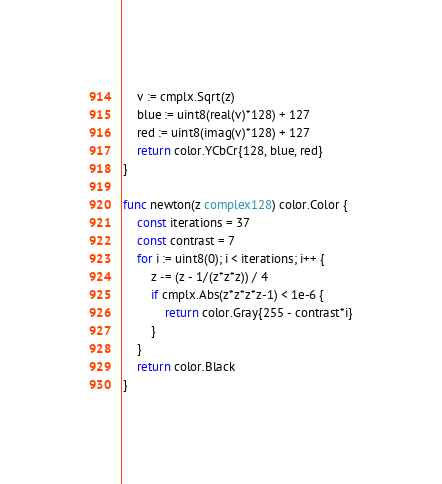<code> <loc_0><loc_0><loc_500><loc_500><_Go_>	v := cmplx.Sqrt(z)
	blue := uint8(real(v)*128) + 127
	red := uint8(imag(v)*128) + 127
	return color.YCbCr{128, blue, red}
}

func newton(z complex128) color.Color {
	const iterations = 37
	const contrast = 7
	for i := uint8(0); i < iterations; i++ {
		z -= (z - 1/(z*z*z)) / 4
		if cmplx.Abs(z*z*z*z-1) < 1e-6 {
			return color.Gray{255 - contrast*i}
		}
	}
	return color.Black
}
</code> 